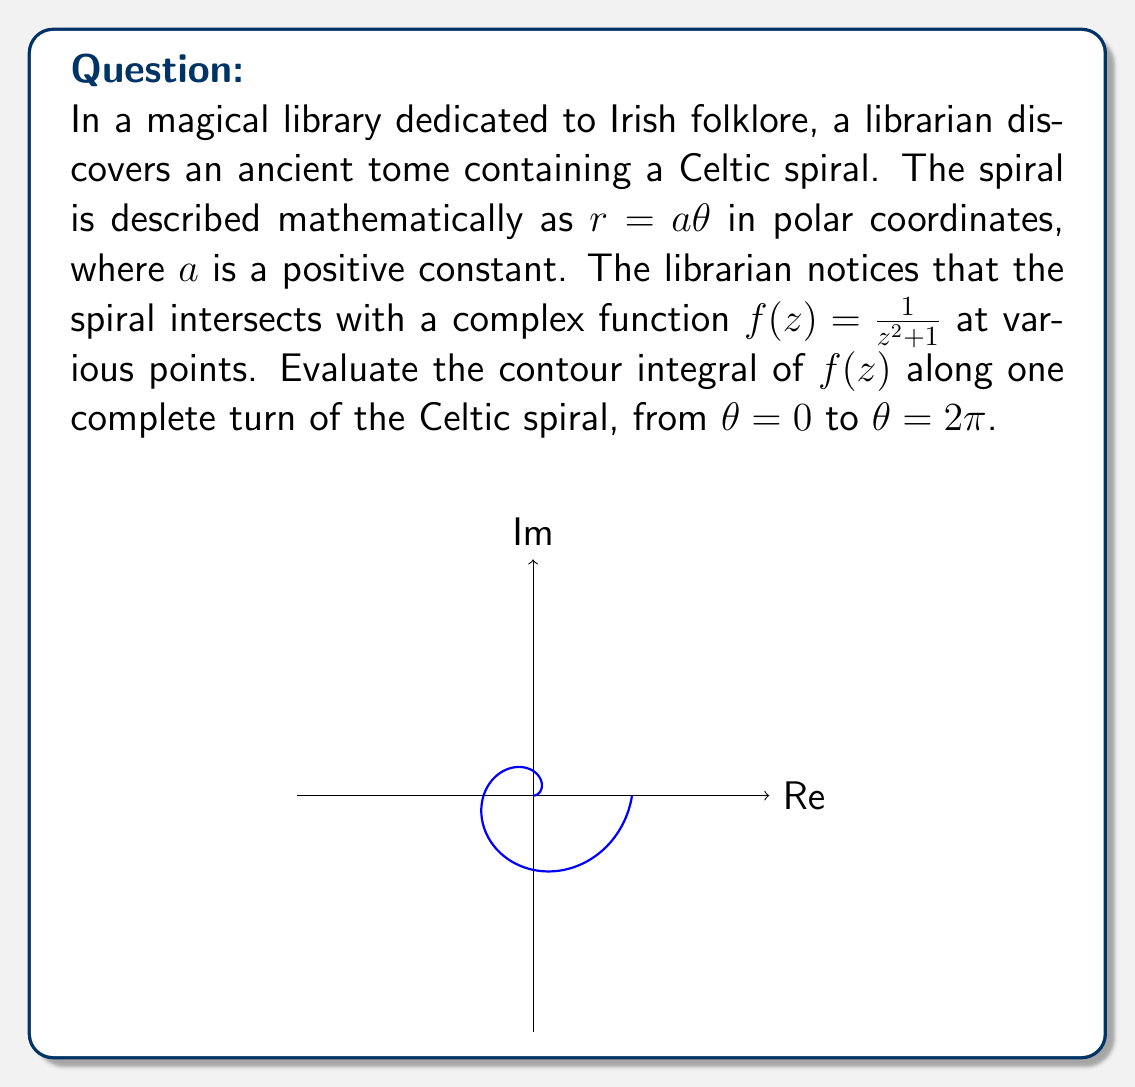Could you help me with this problem? Let's approach this step-by-step:

1) First, we need to parameterize the spiral. In polar coordinates, we have $r = a\theta$. We can convert this to Cartesian coordinates:
   $x = r\cos\theta = a\theta\cos\theta$
   $y = r\sin\theta = a\theta\sin\theta$

2) Now, we can express $z$ in terms of $\theta$:
   $z = x + iy = a\theta(\cos\theta + i\sin\theta) = a\theta e^{i\theta}$

3) We need to find $dz$:
   $dz = a(e^{i\theta} + i\theta e^{i\theta})d\theta$

4) The contour integral is:
   $$\oint_C f(z)dz = \int_0^{2\pi} \frac{1}{(a\theta e^{i\theta})^2 + 1} \cdot a(e^{i\theta} + i\theta e^{i\theta})d\theta$$

5) This integral is quite complex and doesn't have a simple closed form. However, we can use the Residue Theorem to evaluate it.

6) The function $f(z) = \frac{1}{z^2 + 1}$ has poles at $z = \pm i$. We need to check if these poles are inside our contour.

7) The spiral intersects the imaginary axis when $\theta = \frac{\pi}{2}$ and $\theta = \frac{3\pi}{2}$. At these points:
   $r = a\frac{\pi}{2}$ and $r = a\frac{3\pi}{2}$ respectively.

8) If $a\frac{\pi}{2} > 1$, then both poles are inside the contour. If $a\frac{\pi}{2} < 1$, then only the pole at $z = i$ is inside.

9) The residues at these poles are:
   $Res(f, i) = \frac{1}{2i}$
   $Res(f, -i) = -\frac{1}{2i}$

10) By the Residue Theorem:
    If $a\frac{\pi}{2} > 1$: $\oint_C f(z)dz = 2\pi i(Res(f, i) + Res(f, -i)) = 0$
    If $a\frac{\pi}{2} < 1$: $\oint_C f(z)dz = 2\pi i(Res(f, i)) = \pi$
Answer: $\pi$ if $a < \frac{2}{\pi}$, 0 if $a > \frac{2}{\pi}$ 